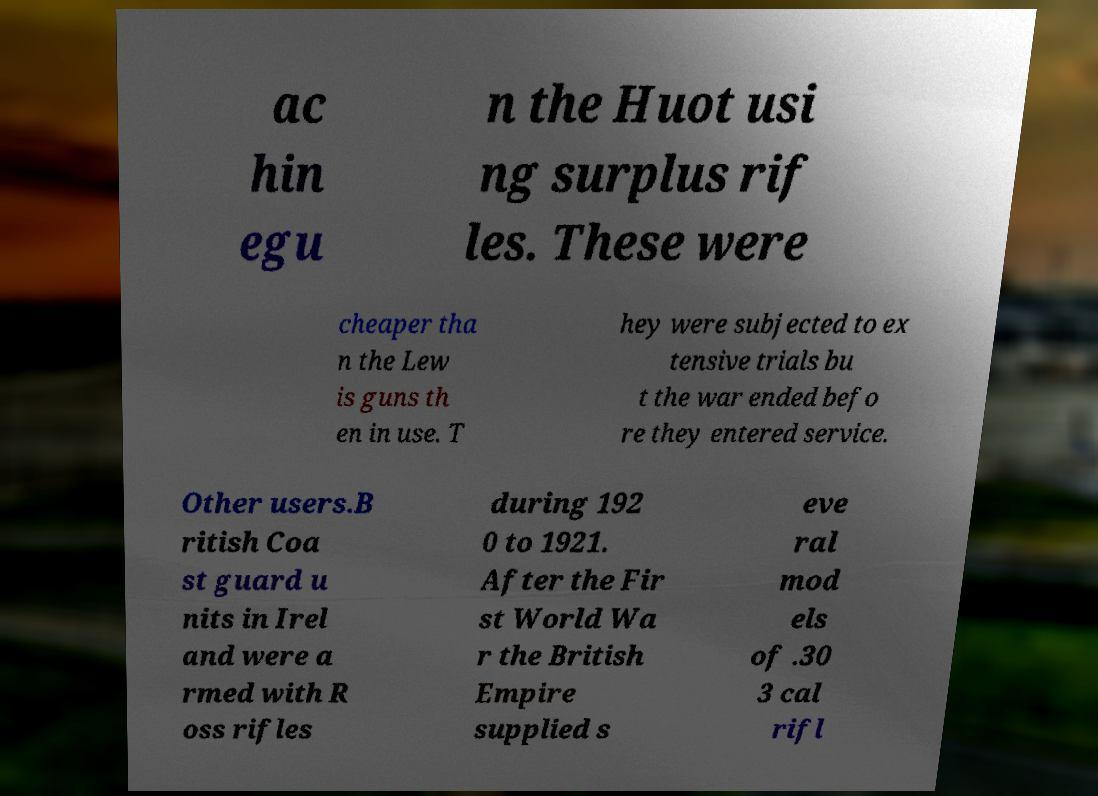What messages or text are displayed in this image? I need them in a readable, typed format. ac hin egu n the Huot usi ng surplus rif les. These were cheaper tha n the Lew is guns th en in use. T hey were subjected to ex tensive trials bu t the war ended befo re they entered service. Other users.B ritish Coa st guard u nits in Irel and were a rmed with R oss rifles during 192 0 to 1921. After the Fir st World Wa r the British Empire supplied s eve ral mod els of .30 3 cal rifl 